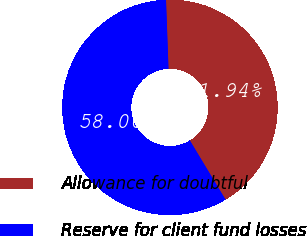<chart> <loc_0><loc_0><loc_500><loc_500><pie_chart><fcel>Allowance for doubtful<fcel>Reserve for client fund losses<nl><fcel>41.94%<fcel>58.06%<nl></chart> 